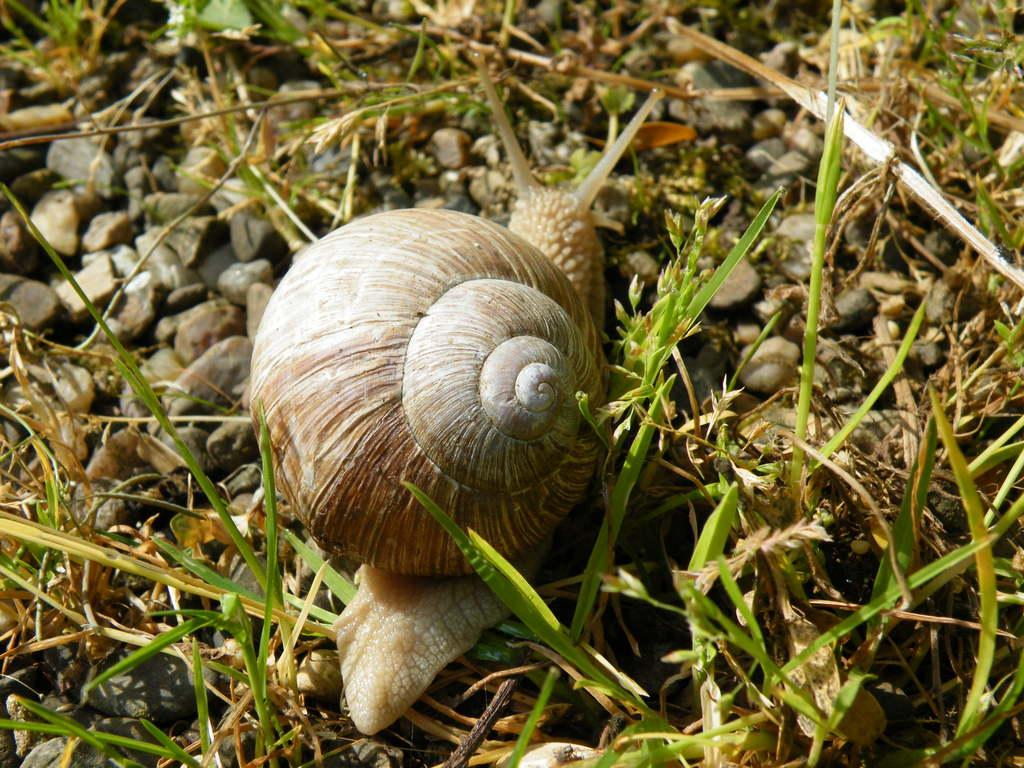What type of animal can be seen on the stones in the image? There is a snail on the stones in the image. What type of vegetation is present at the bottom of the image? There is grass at the bottom of the image. What type of surface is present on either side of the image? There are stones on either side of the image. What type of sign can be seen in the image? There is no sign present in the image. How many wings can be seen on the snail in the image? Snails do not have wings, so there are no wings visible on the snail in the image. 